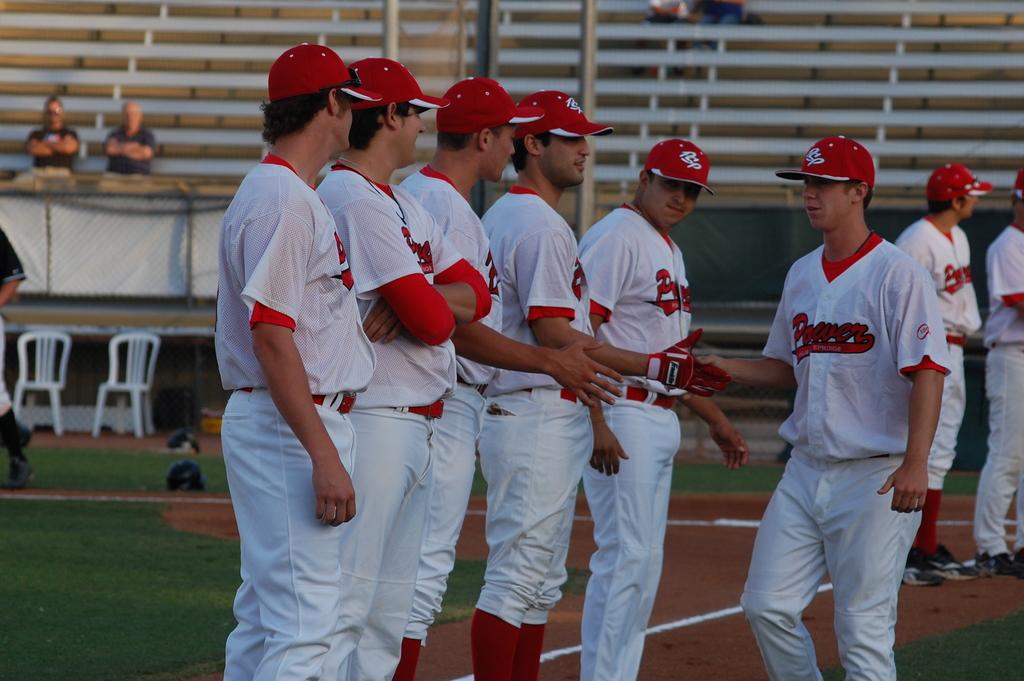What is the team name on the jersey?
Offer a terse response. Power. 